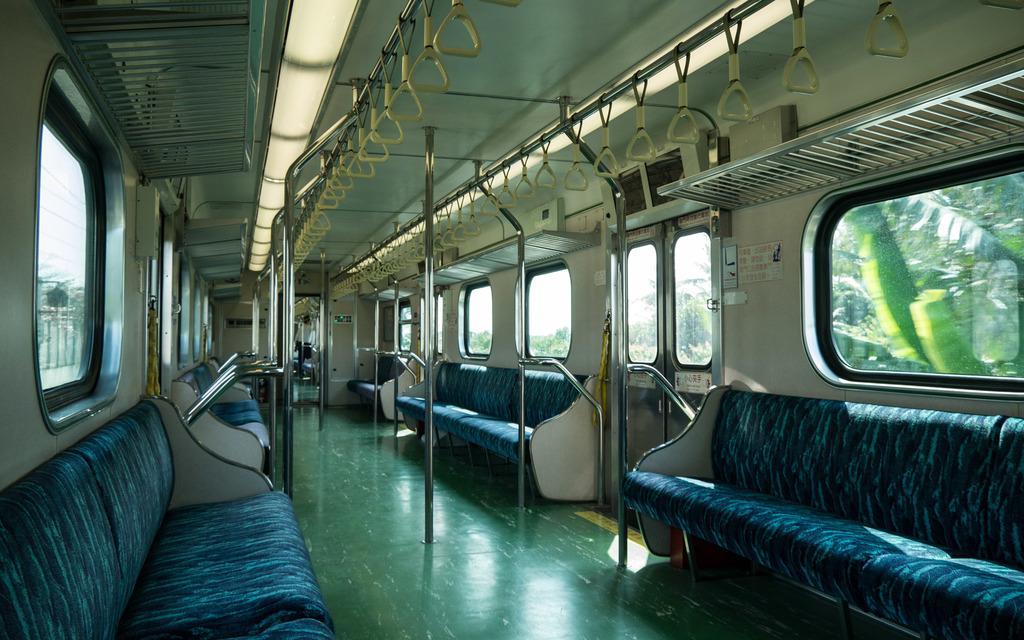Describe this image in one or two sentences. In this image we can see inner view of a train. In the train there are grills, doors, rods, seats, handles and windows. In the background we can see trees, sky and electric poles. 